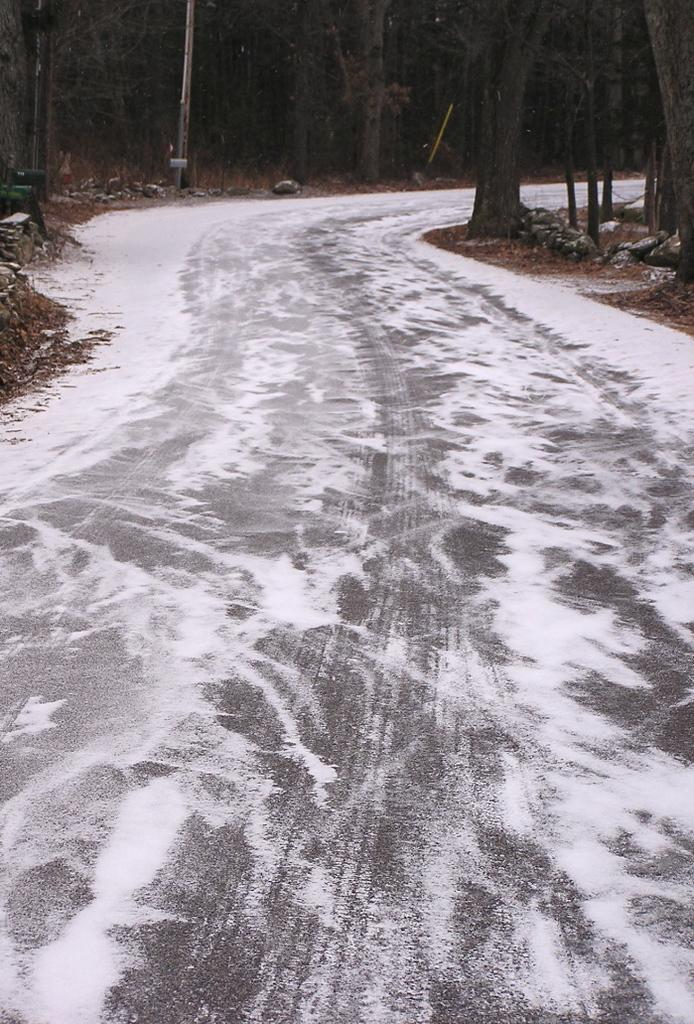What is the condition of the road in the image? The road has frost in the image. What type of vegetation can be seen in the image? There is a group of trees in the image. What object is present in the image that might be used for signage or lighting? There is a pole in the image. How many cows are grazing in the field next to the trees in the image? There are no cows or fields present in the image; it features a road with frost, a group of trees, and a pole. What type of star can be seen shining brightly in the sky in the image? There is no star visible in the image; it only shows a road with frost, a group of trees, and a pole. 